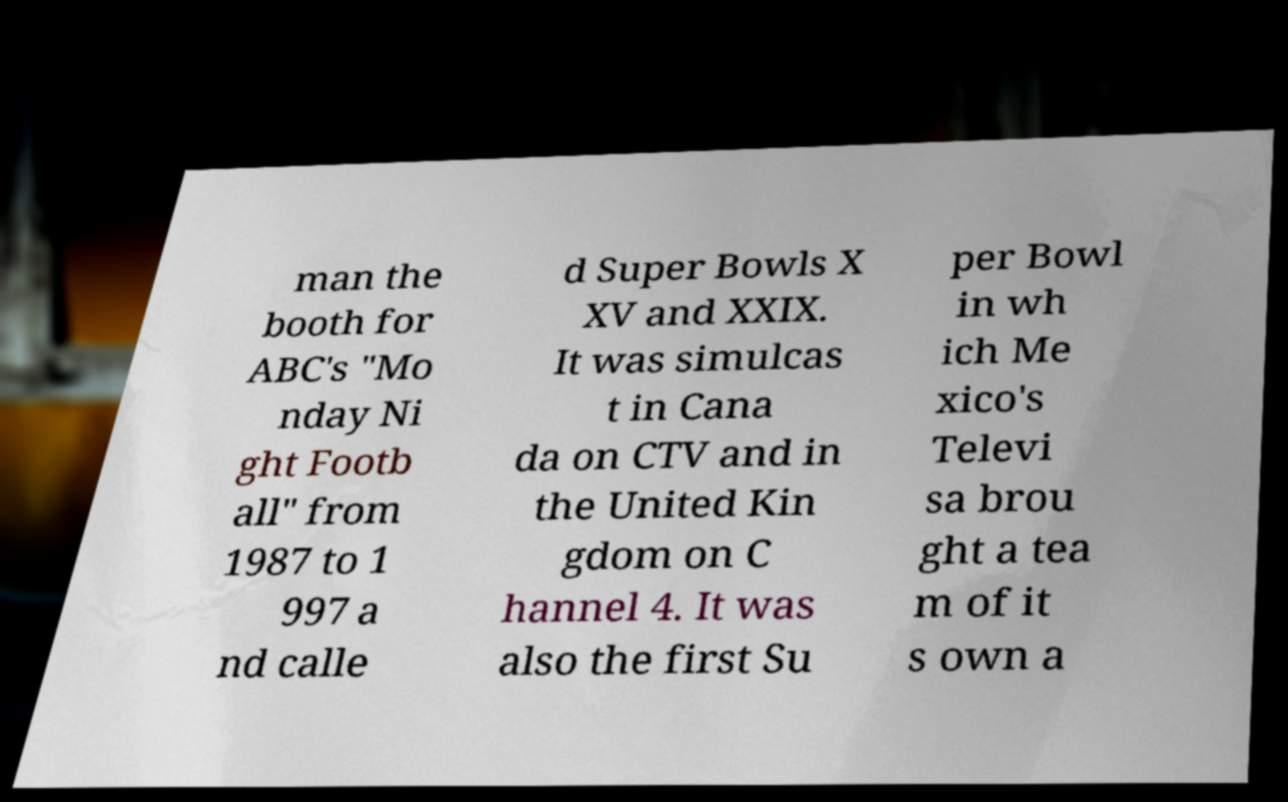Can you accurately transcribe the text from the provided image for me? man the booth for ABC's "Mo nday Ni ght Footb all" from 1987 to 1 997 a nd calle d Super Bowls X XV and XXIX. It was simulcas t in Cana da on CTV and in the United Kin gdom on C hannel 4. It was also the first Su per Bowl in wh ich Me xico's Televi sa brou ght a tea m of it s own a 